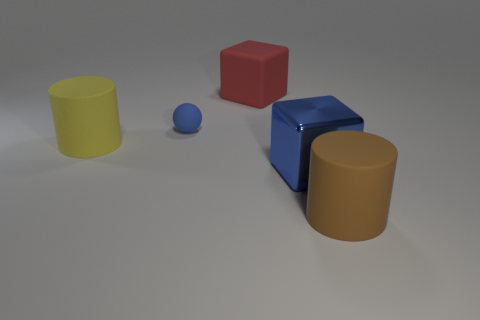Add 4 big yellow things. How many objects exist? 9 Subtract all brown metal spheres. Subtract all rubber objects. How many objects are left? 1 Add 1 spheres. How many spheres are left? 2 Add 1 small things. How many small things exist? 2 Subtract 0 yellow cubes. How many objects are left? 5 Subtract all cylinders. How many objects are left? 3 